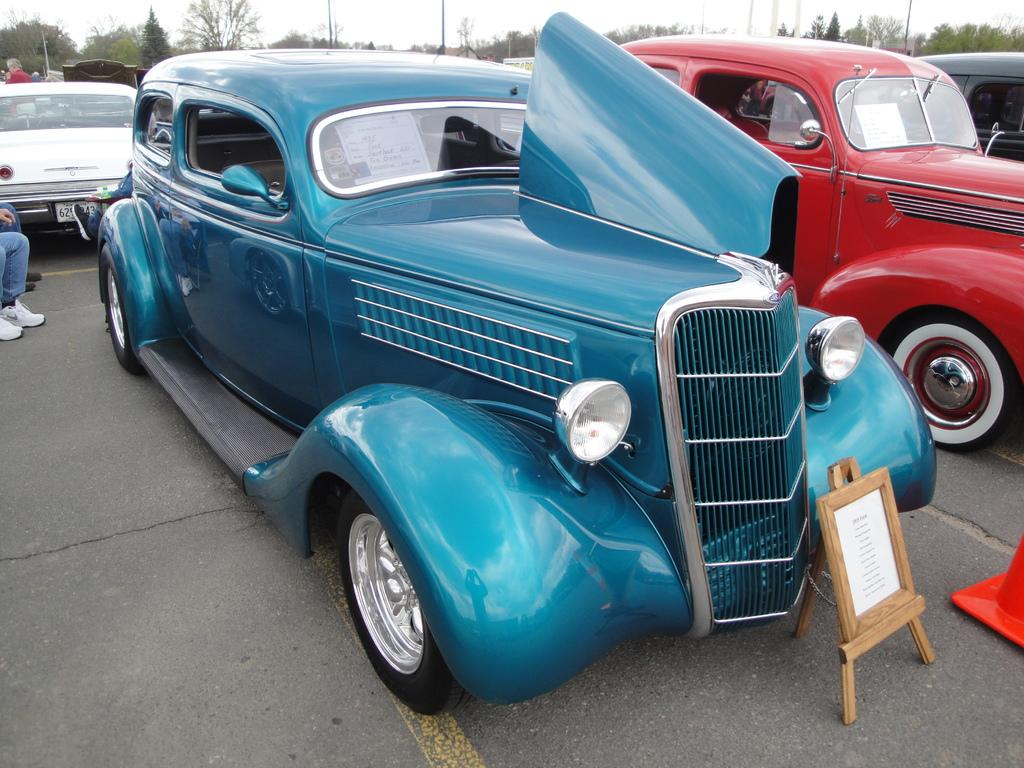What types of vehicles can be seen in the image? There are many vehicles of different colors in the image. Can you describe the person in the image? There is a person wearing clothes and shoes in the image. What is the setting of the image? There is a road in the image. What else can be seen in the image besides vehicles and the person? There is a board and trees in the image. What is visible in the background of the image? The sky is visible in the image. How many crates are being used by the donkey in the image? There is no donkey or crate present in the image. What type of battle is taking place in the image? There is no battle present in the image; it features vehicles, a person, a road, a board, trees, and the sky. 